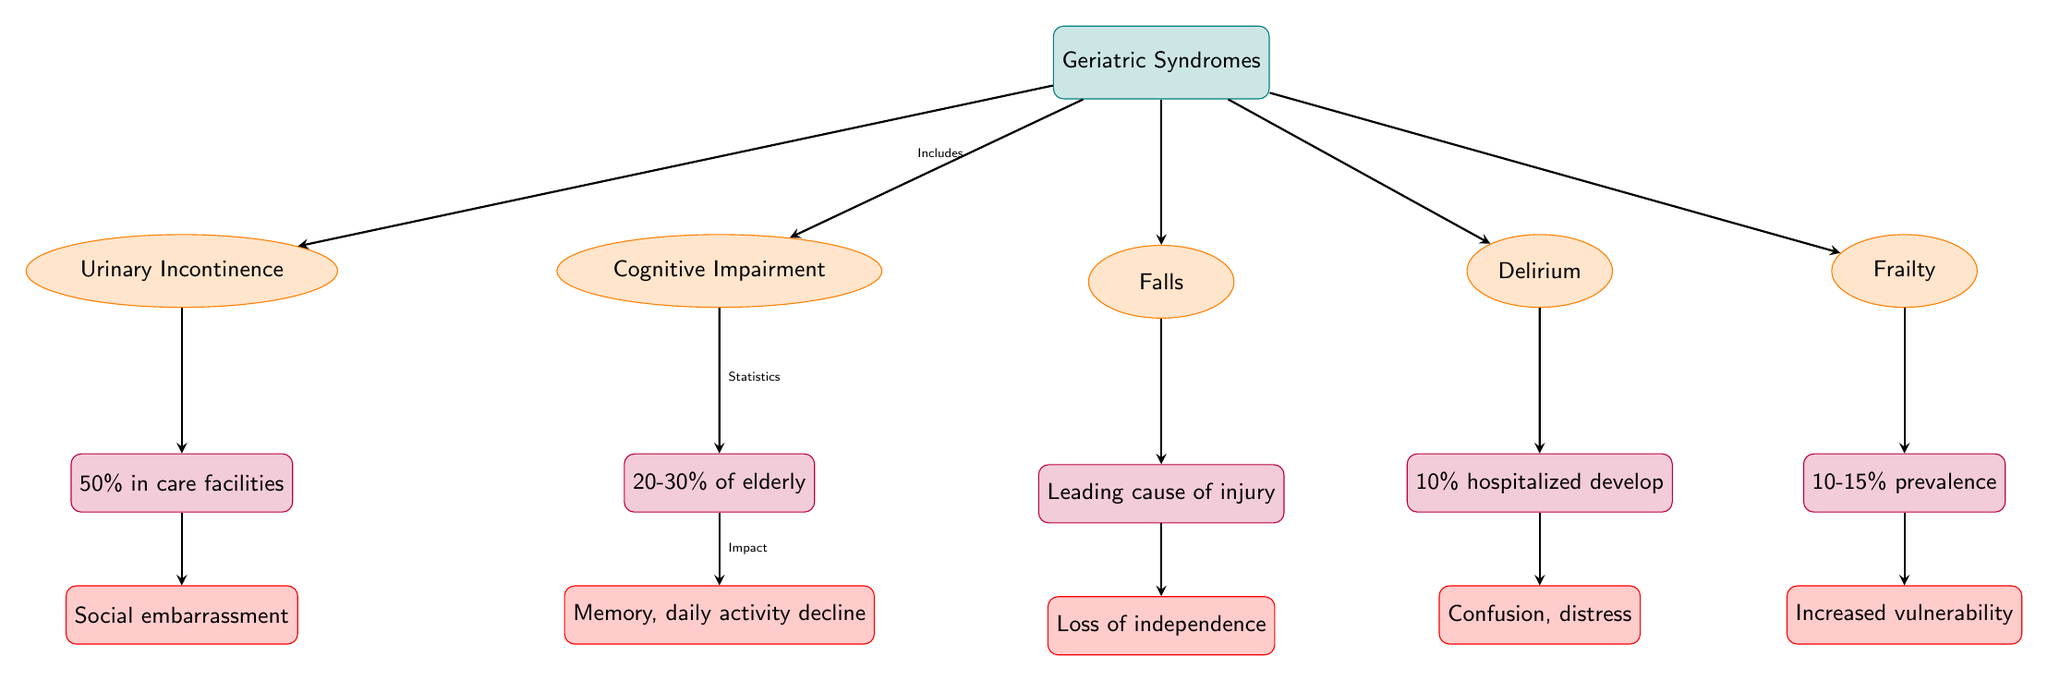What are the five geriatric syndromes listed in the diagram? The diagram explicitly shows five geriatric syndromes: Cognitive Impairment, Falls, Delirium, Urinary Incontinence, and Frailty. Each of these syndromes is depicted within an ellipse shape.
Answer: Cognitive Impairment, Falls, Delirium, Urinary Incontinence, Frailty What percentage of elderly individuals are affected by cognitive impairment? The statistic associated with cognitive impairment states that 20-30% of elderly individuals are affected. This percentage is represented in a purple rectangle under the Cognitive Impairment node.
Answer: 20-30% What is the leading cause of injury among the elderly? Under the Falls node, the statistic specifies that Falls are the leading cause of injury among the elderly, indicating its significant impact on their health.
Answer: Leading cause of injury How many hospitalized patients develop delirium? According to the delirium node, the statistic indicates that 10% of hospitalized patients develop delirium, which is noted in a purple rectangle below the Delirium node.
Answer: 10% Which geriatric syndrome has a prevalence of 10-15%? Frailty is noted to have a prevalence of 10-15%, as indicated in the purple rectangle positioned below the Frailty node in the diagram.
Answer: 10-15% Describe the impact of urinary incontinence. The impact of urinary incontinence is stated to cause social embarrassment. This information is depicted below the Urinary Incontinence statistic in the diagram.
Answer: Social embarrassment Which syndrome is linked to a decline in memory and daily activities? Cognitive Impairment is associated with memory decline and a decrease in the ability to perform daily activities, as noted in the impact area below the corresponding statistic.
Answer: Memory, daily activity decline What indicates the impact of falls on the elderly? The impact of falls on the elderly is described as a loss of independence, as shown in the impact rectangle below the Falls statistic in the diagram.
Answer: Loss of independence What is the general trend in the prevalence of frailty among the elderly? The diagram specifies that frailty has a prevalence rate of 10-15%, indicating that a significant proportion of elderly individuals experience this syndrome.
Answer: Increased vulnerability 